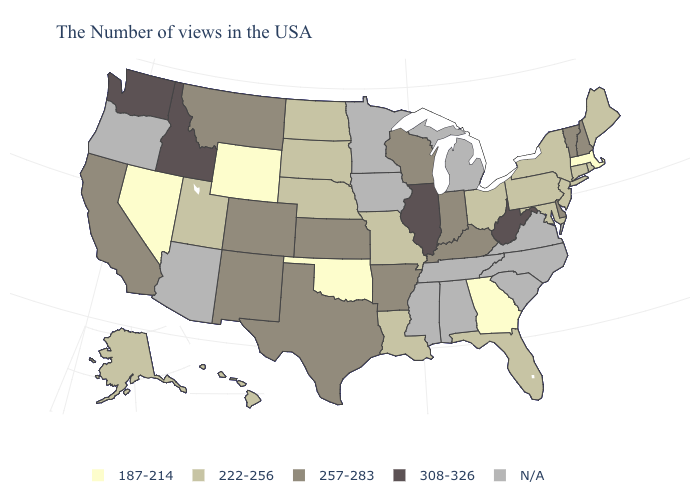Which states have the highest value in the USA?
Short answer required. West Virginia, Illinois, Idaho, Washington. Is the legend a continuous bar?
Quick response, please. No. Name the states that have a value in the range N/A?
Concise answer only. Virginia, North Carolina, South Carolina, Michigan, Alabama, Tennessee, Mississippi, Minnesota, Iowa, Arizona, Oregon. What is the lowest value in the USA?
Quick response, please. 187-214. Among the states that border New Jersey , which have the highest value?
Be succinct. Delaware. Does the first symbol in the legend represent the smallest category?
Give a very brief answer. Yes. What is the value of Maine?
Give a very brief answer. 222-256. What is the value of Alabama?
Be succinct. N/A. Does the map have missing data?
Write a very short answer. Yes. Name the states that have a value in the range 187-214?
Answer briefly. Massachusetts, Georgia, Oklahoma, Wyoming, Nevada. Name the states that have a value in the range N/A?
Answer briefly. Virginia, North Carolina, South Carolina, Michigan, Alabama, Tennessee, Mississippi, Minnesota, Iowa, Arizona, Oregon. Among the states that border New York , which have the highest value?
Be succinct. Vermont. What is the highest value in the USA?
Short answer required. 308-326. What is the highest value in the USA?
Answer briefly. 308-326. 